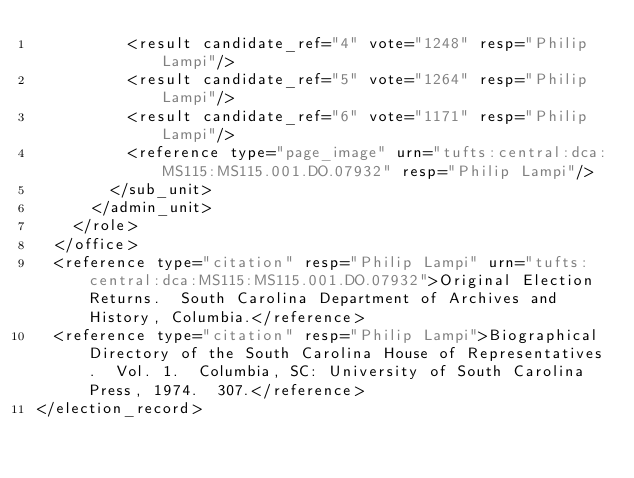Convert code to text. <code><loc_0><loc_0><loc_500><loc_500><_XML_>					<result candidate_ref="4" vote="1248" resp="Philip Lampi"/>
					<result candidate_ref="5" vote="1264" resp="Philip Lampi"/>
					<result candidate_ref="6" vote="1171" resp="Philip Lampi"/>
					<reference type="page_image" urn="tufts:central:dca:MS115:MS115.001.DO.07932" resp="Philip Lampi"/>
				</sub_unit>
			</admin_unit>
		</role>
	</office>
	<reference type="citation" resp="Philip Lampi" urn="tufts:central:dca:MS115:MS115.001.DO.07932">Original Election Returns.  South Carolina Department of Archives and History, Columbia.</reference>
	<reference type="citation" resp="Philip Lampi">Biographical Directory of the South Carolina House of Representatives.  Vol. 1.  Columbia, SC: University of South Carolina Press, 1974.  307.</reference>
</election_record>
</code> 